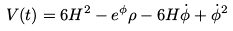<formula> <loc_0><loc_0><loc_500><loc_500>V ( t ) = 6 H ^ { 2 } - e ^ { \phi } \rho - 6 H \dot { \phi } + \dot { \phi } ^ { 2 }</formula> 